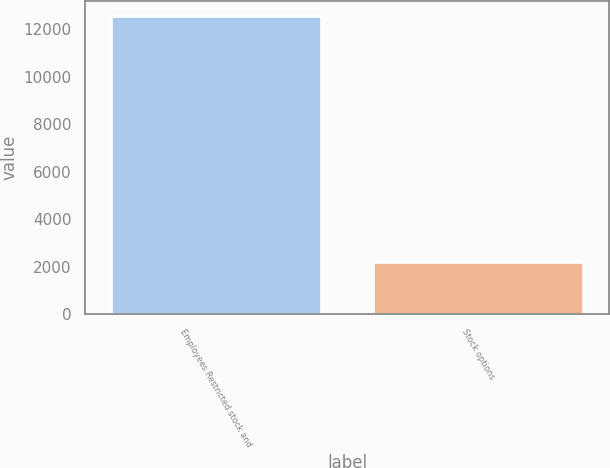Convert chart to OTSL. <chart><loc_0><loc_0><loc_500><loc_500><bar_chart><fcel>Employees Restricted stock and<fcel>Stock options<nl><fcel>12559<fcel>2193<nl></chart> 